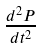Convert formula to latex. <formula><loc_0><loc_0><loc_500><loc_500>\frac { d ^ { 2 } P } { d t ^ { 2 } }</formula> 